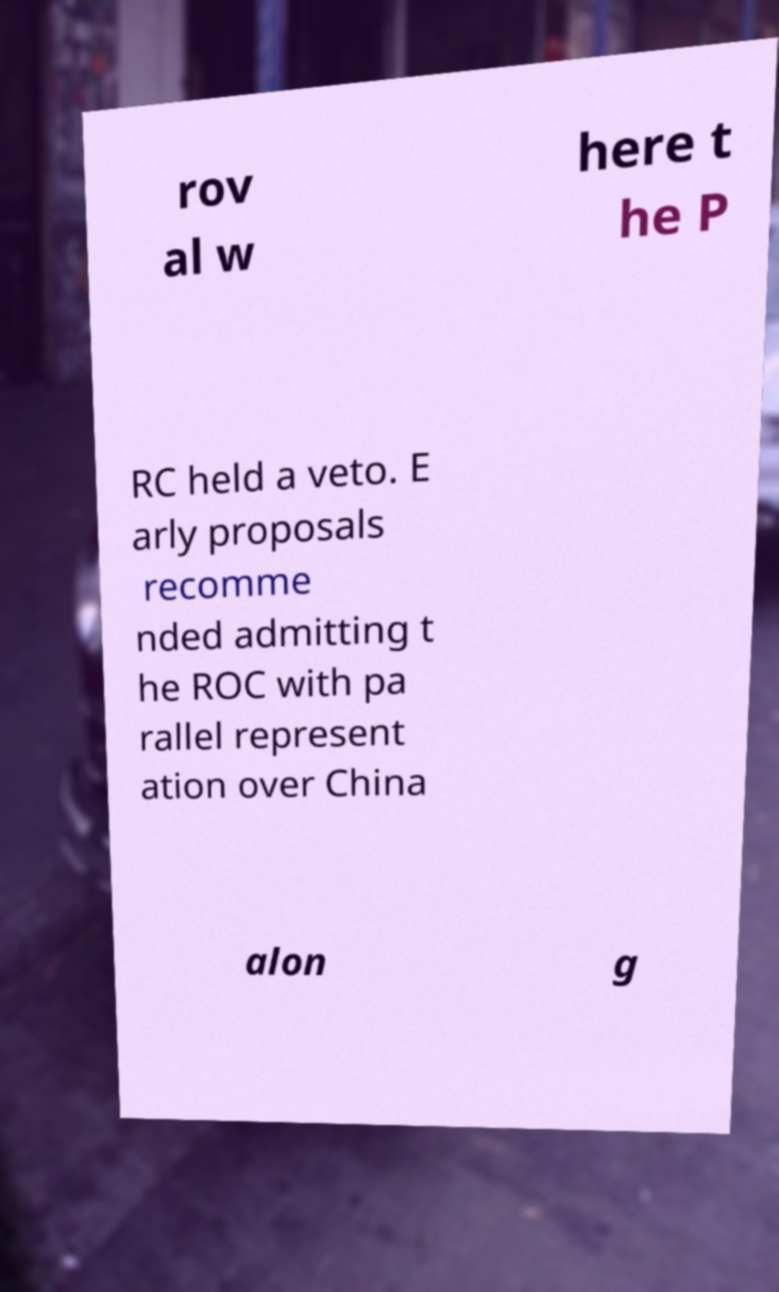Please identify and transcribe the text found in this image. rov al w here t he P RC held a veto. E arly proposals recomme nded admitting t he ROC with pa rallel represent ation over China alon g 